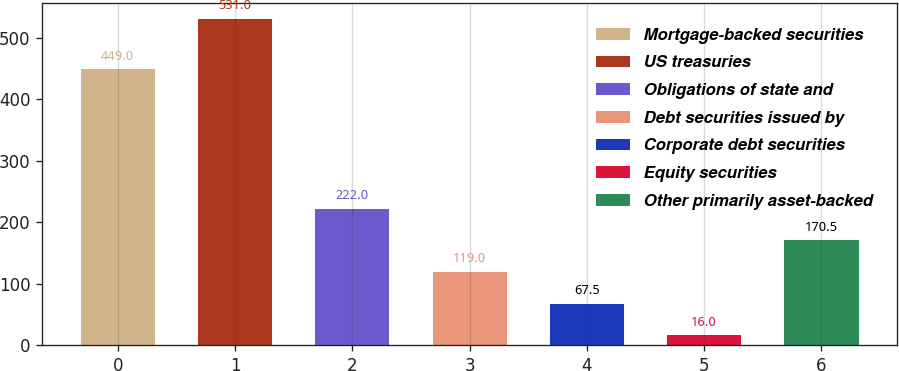Convert chart to OTSL. <chart><loc_0><loc_0><loc_500><loc_500><bar_chart><fcel>Mortgage-backed securities<fcel>US treasuries<fcel>Obligations of state and<fcel>Debt securities issued by<fcel>Corporate debt securities<fcel>Equity securities<fcel>Other primarily asset-backed<nl><fcel>449<fcel>531<fcel>222<fcel>119<fcel>67.5<fcel>16<fcel>170.5<nl></chart> 